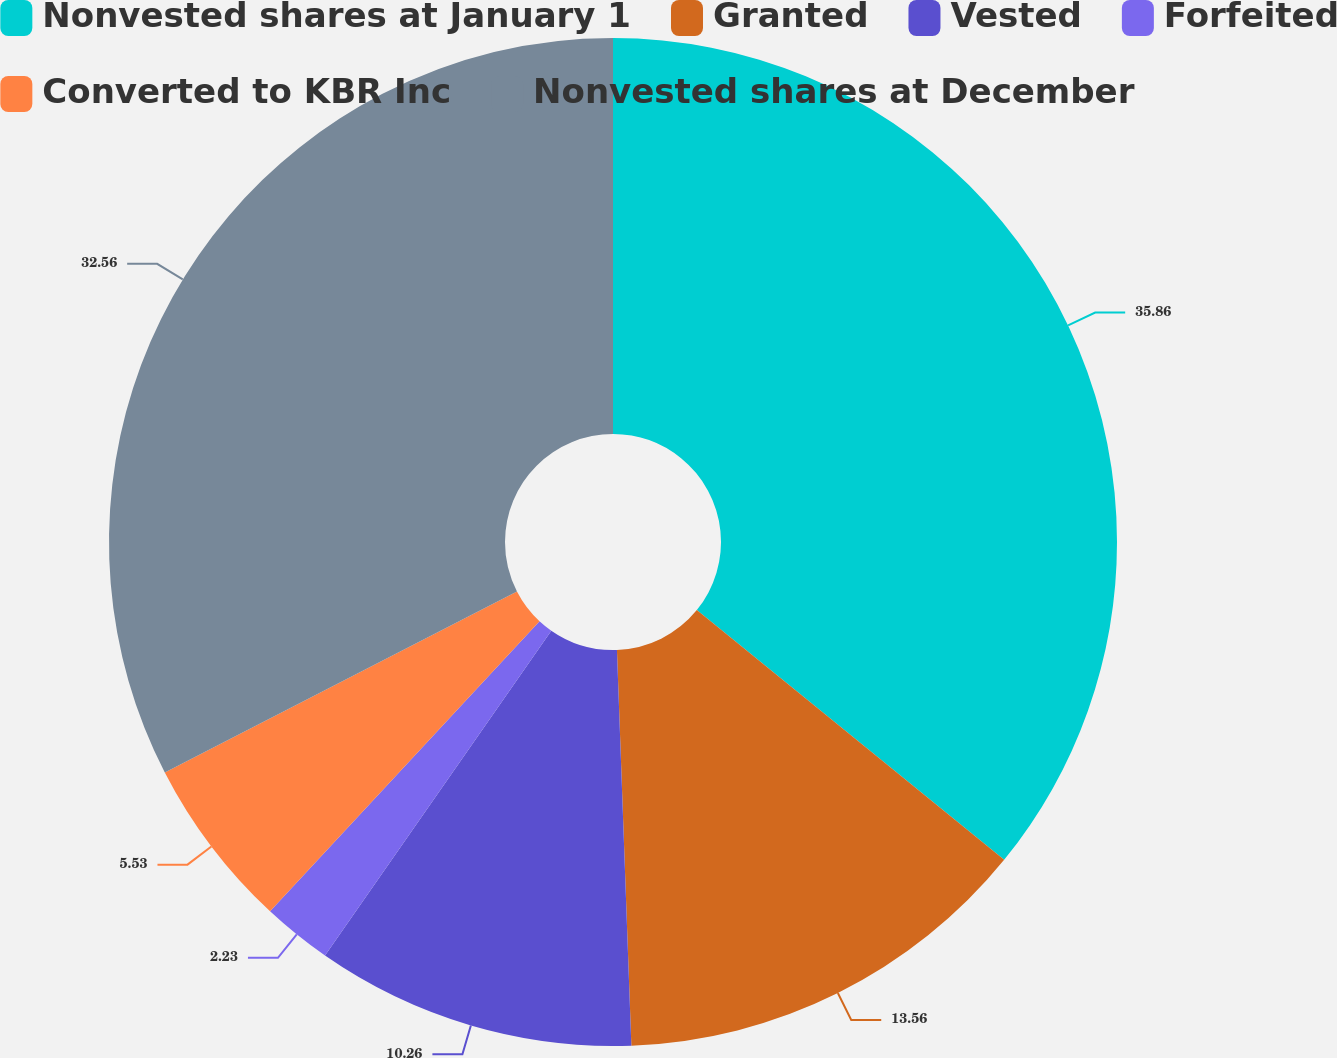Convert chart to OTSL. <chart><loc_0><loc_0><loc_500><loc_500><pie_chart><fcel>Nonvested shares at January 1<fcel>Granted<fcel>Vested<fcel>Forfeited<fcel>Converted to KBR Inc<fcel>Nonvested shares at December<nl><fcel>35.86%<fcel>13.56%<fcel>10.26%<fcel>2.23%<fcel>5.53%<fcel>32.56%<nl></chart> 